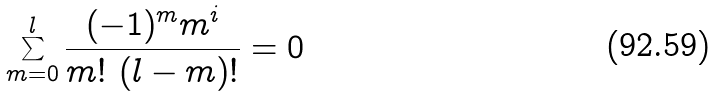<formula> <loc_0><loc_0><loc_500><loc_500>\sum _ { m = 0 } ^ { l } \frac { ( - 1 ) ^ { m } m ^ { i } } { m ! \ ( l - m ) ! } = 0</formula> 